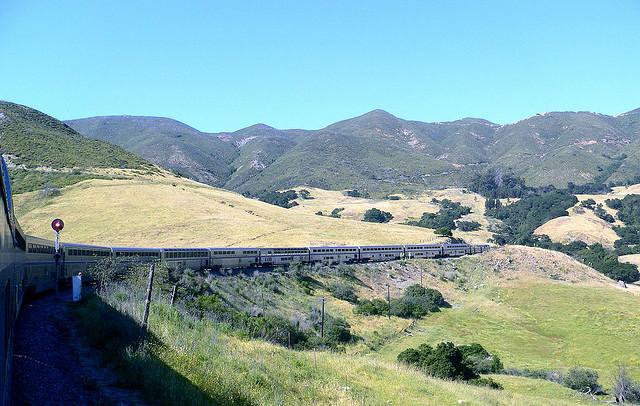What color is the light?
Be succinct. Red. Through what country is this train traveling?
Write a very short answer. America. Is the train going fast?
Concise answer only. Yes. 